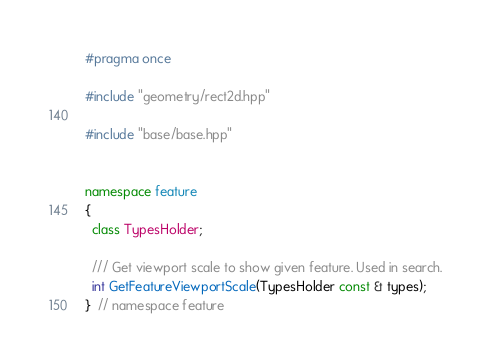<code> <loc_0><loc_0><loc_500><loc_500><_C++_>#pragma once

#include "geometry/rect2d.hpp"

#include "base/base.hpp"


namespace feature
{
  class TypesHolder;

  /// Get viewport scale to show given feature. Used in search.
  int GetFeatureViewportScale(TypesHolder const & types);
}  // namespace feature
</code> 